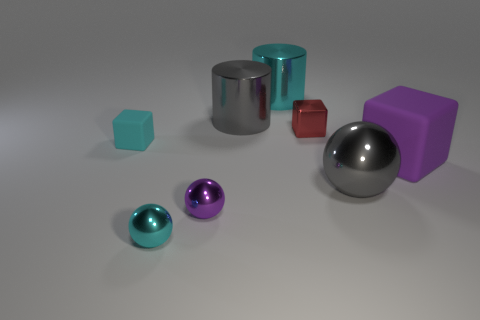What number of purple things are either small metal blocks or small spheres?
Ensure brevity in your answer.  1. Is the number of big gray shiny things that are on the right side of the large cyan metallic cylinder greater than the number of red matte spheres?
Ensure brevity in your answer.  Yes. Is there a large ball of the same color as the large rubber block?
Your answer should be compact. No. What size is the cyan shiny ball?
Provide a short and direct response. Small. Does the big cube have the same color as the tiny rubber thing?
Your answer should be very brief. No. How many objects are big spheres or large gray metal objects behind the big matte cube?
Offer a very short reply. 2. There is a cyan thing that is right of the gray shiny thing that is left of the tiny red shiny thing; what number of rubber cubes are behind it?
Keep it short and to the point. 0. There is a ball that is the same color as the big cube; what is it made of?
Make the answer very short. Metal. How many large blue matte things are there?
Your answer should be compact. 0. Does the gray shiny thing that is in front of the red cube have the same size as the big gray cylinder?
Offer a very short reply. Yes. 